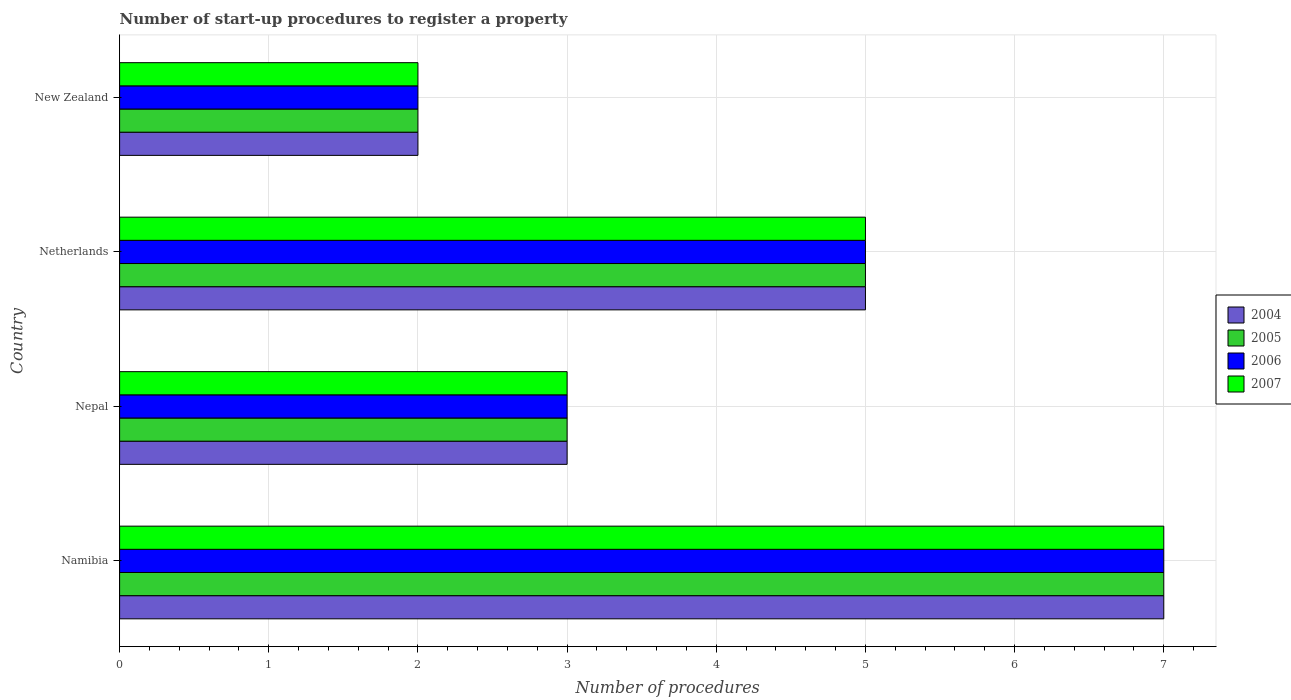How many different coloured bars are there?
Make the answer very short. 4. Are the number of bars per tick equal to the number of legend labels?
Your answer should be compact. Yes. Are the number of bars on each tick of the Y-axis equal?
Your answer should be very brief. Yes. What is the label of the 1st group of bars from the top?
Provide a short and direct response. New Zealand. What is the number of procedures required to register a property in 2007 in New Zealand?
Give a very brief answer. 2. Across all countries, what is the maximum number of procedures required to register a property in 2004?
Give a very brief answer. 7. In which country was the number of procedures required to register a property in 2004 maximum?
Keep it short and to the point. Namibia. In which country was the number of procedures required to register a property in 2004 minimum?
Give a very brief answer. New Zealand. What is the total number of procedures required to register a property in 2006 in the graph?
Your response must be concise. 17. What is the difference between the number of procedures required to register a property in 2006 in Nepal and that in Netherlands?
Keep it short and to the point. -2. What is the average number of procedures required to register a property in 2005 per country?
Provide a short and direct response. 4.25. What is the ratio of the number of procedures required to register a property in 2005 in Namibia to that in Nepal?
Offer a terse response. 2.33. What is the difference between the highest and the second highest number of procedures required to register a property in 2005?
Ensure brevity in your answer.  2. What is the difference between the highest and the lowest number of procedures required to register a property in 2007?
Make the answer very short. 5. Is it the case that in every country, the sum of the number of procedures required to register a property in 2007 and number of procedures required to register a property in 2006 is greater than the sum of number of procedures required to register a property in 2005 and number of procedures required to register a property in 2004?
Your answer should be very brief. No. What does the 2nd bar from the top in Namibia represents?
Your response must be concise. 2006. What does the 4th bar from the bottom in Namibia represents?
Give a very brief answer. 2007. Is it the case that in every country, the sum of the number of procedures required to register a property in 2006 and number of procedures required to register a property in 2004 is greater than the number of procedures required to register a property in 2007?
Provide a short and direct response. Yes. How many bars are there?
Your answer should be very brief. 16. Are all the bars in the graph horizontal?
Provide a short and direct response. Yes. How many countries are there in the graph?
Your answer should be compact. 4. Does the graph contain grids?
Provide a succinct answer. Yes. Where does the legend appear in the graph?
Make the answer very short. Center right. How many legend labels are there?
Give a very brief answer. 4. What is the title of the graph?
Keep it short and to the point. Number of start-up procedures to register a property. Does "1962" appear as one of the legend labels in the graph?
Your answer should be compact. No. What is the label or title of the X-axis?
Keep it short and to the point. Number of procedures. What is the label or title of the Y-axis?
Your response must be concise. Country. What is the Number of procedures of 2006 in Namibia?
Offer a terse response. 7. What is the Number of procedures of 2006 in Nepal?
Offer a terse response. 3. What is the Number of procedures of 2005 in Netherlands?
Offer a terse response. 5. What is the Number of procedures in 2006 in Netherlands?
Provide a succinct answer. 5. What is the Number of procedures in 2004 in New Zealand?
Your answer should be compact. 2. Across all countries, what is the maximum Number of procedures in 2004?
Offer a terse response. 7. Across all countries, what is the maximum Number of procedures of 2005?
Offer a very short reply. 7. Across all countries, what is the maximum Number of procedures of 2007?
Ensure brevity in your answer.  7. Across all countries, what is the minimum Number of procedures in 2006?
Your answer should be very brief. 2. Across all countries, what is the minimum Number of procedures in 2007?
Ensure brevity in your answer.  2. What is the total Number of procedures of 2007 in the graph?
Offer a terse response. 17. What is the difference between the Number of procedures of 2005 in Namibia and that in Nepal?
Ensure brevity in your answer.  4. What is the difference between the Number of procedures in 2006 in Namibia and that in Nepal?
Provide a succinct answer. 4. What is the difference between the Number of procedures in 2004 in Namibia and that in Netherlands?
Provide a succinct answer. 2. What is the difference between the Number of procedures of 2006 in Namibia and that in Netherlands?
Offer a terse response. 2. What is the difference between the Number of procedures of 2007 in Namibia and that in Netherlands?
Provide a short and direct response. 2. What is the difference between the Number of procedures of 2004 in Namibia and that in New Zealand?
Keep it short and to the point. 5. What is the difference between the Number of procedures in 2005 in Namibia and that in New Zealand?
Offer a terse response. 5. What is the difference between the Number of procedures of 2007 in Namibia and that in New Zealand?
Your response must be concise. 5. What is the difference between the Number of procedures in 2004 in Nepal and that in Netherlands?
Your answer should be compact. -2. What is the difference between the Number of procedures in 2006 in Nepal and that in Netherlands?
Offer a very short reply. -2. What is the difference between the Number of procedures of 2007 in Nepal and that in Netherlands?
Give a very brief answer. -2. What is the difference between the Number of procedures in 2005 in Nepal and that in New Zealand?
Keep it short and to the point. 1. What is the difference between the Number of procedures in 2006 in Nepal and that in New Zealand?
Provide a short and direct response. 1. What is the difference between the Number of procedures of 2007 in Nepal and that in New Zealand?
Offer a terse response. 1. What is the difference between the Number of procedures in 2004 in Netherlands and that in New Zealand?
Your response must be concise. 3. What is the difference between the Number of procedures of 2005 in Netherlands and that in New Zealand?
Ensure brevity in your answer.  3. What is the difference between the Number of procedures of 2007 in Netherlands and that in New Zealand?
Your answer should be compact. 3. What is the difference between the Number of procedures of 2005 in Namibia and the Number of procedures of 2006 in Nepal?
Offer a very short reply. 4. What is the difference between the Number of procedures of 2006 in Namibia and the Number of procedures of 2007 in Nepal?
Give a very brief answer. 4. What is the difference between the Number of procedures in 2005 in Namibia and the Number of procedures in 2006 in Netherlands?
Your answer should be compact. 2. What is the difference between the Number of procedures of 2005 in Namibia and the Number of procedures of 2007 in Netherlands?
Offer a very short reply. 2. What is the difference between the Number of procedures of 2006 in Namibia and the Number of procedures of 2007 in Netherlands?
Provide a short and direct response. 2. What is the difference between the Number of procedures in 2004 in Namibia and the Number of procedures in 2007 in New Zealand?
Your answer should be very brief. 5. What is the difference between the Number of procedures in 2005 in Namibia and the Number of procedures in 2007 in New Zealand?
Keep it short and to the point. 5. What is the difference between the Number of procedures of 2005 in Nepal and the Number of procedures of 2006 in Netherlands?
Offer a very short reply. -2. What is the difference between the Number of procedures in 2005 in Nepal and the Number of procedures in 2007 in Netherlands?
Provide a succinct answer. -2. What is the difference between the Number of procedures of 2004 in Nepal and the Number of procedures of 2006 in New Zealand?
Provide a short and direct response. 1. What is the difference between the Number of procedures of 2004 in Nepal and the Number of procedures of 2007 in New Zealand?
Ensure brevity in your answer.  1. What is the difference between the Number of procedures in 2006 in Nepal and the Number of procedures in 2007 in New Zealand?
Offer a very short reply. 1. What is the difference between the Number of procedures of 2004 in Netherlands and the Number of procedures of 2006 in New Zealand?
Your answer should be very brief. 3. What is the difference between the Number of procedures of 2004 in Netherlands and the Number of procedures of 2007 in New Zealand?
Keep it short and to the point. 3. What is the difference between the Number of procedures in 2005 in Netherlands and the Number of procedures in 2006 in New Zealand?
Your response must be concise. 3. What is the average Number of procedures in 2004 per country?
Provide a short and direct response. 4.25. What is the average Number of procedures in 2005 per country?
Offer a terse response. 4.25. What is the average Number of procedures of 2006 per country?
Your answer should be very brief. 4.25. What is the average Number of procedures in 2007 per country?
Your response must be concise. 4.25. What is the difference between the Number of procedures of 2004 and Number of procedures of 2006 in Namibia?
Keep it short and to the point. 0. What is the difference between the Number of procedures in 2005 and Number of procedures in 2006 in Namibia?
Give a very brief answer. 0. What is the difference between the Number of procedures of 2005 and Number of procedures of 2007 in Namibia?
Give a very brief answer. 0. What is the difference between the Number of procedures of 2004 and Number of procedures of 2005 in Nepal?
Ensure brevity in your answer.  0. What is the difference between the Number of procedures of 2004 and Number of procedures of 2007 in Nepal?
Ensure brevity in your answer.  0. What is the difference between the Number of procedures in 2005 and Number of procedures in 2006 in Nepal?
Provide a short and direct response. 0. What is the difference between the Number of procedures of 2005 and Number of procedures of 2007 in Netherlands?
Your answer should be very brief. 0. What is the difference between the Number of procedures of 2004 and Number of procedures of 2005 in New Zealand?
Keep it short and to the point. 0. What is the difference between the Number of procedures in 2004 and Number of procedures in 2006 in New Zealand?
Your response must be concise. 0. What is the difference between the Number of procedures of 2004 and Number of procedures of 2007 in New Zealand?
Provide a short and direct response. 0. What is the difference between the Number of procedures of 2005 and Number of procedures of 2006 in New Zealand?
Keep it short and to the point. 0. What is the difference between the Number of procedures of 2005 and Number of procedures of 2007 in New Zealand?
Make the answer very short. 0. What is the difference between the Number of procedures in 2006 and Number of procedures in 2007 in New Zealand?
Provide a succinct answer. 0. What is the ratio of the Number of procedures of 2004 in Namibia to that in Nepal?
Your answer should be compact. 2.33. What is the ratio of the Number of procedures of 2005 in Namibia to that in Nepal?
Your response must be concise. 2.33. What is the ratio of the Number of procedures in 2006 in Namibia to that in Nepal?
Ensure brevity in your answer.  2.33. What is the ratio of the Number of procedures of 2007 in Namibia to that in Nepal?
Your answer should be compact. 2.33. What is the ratio of the Number of procedures of 2004 in Namibia to that in Netherlands?
Ensure brevity in your answer.  1.4. What is the ratio of the Number of procedures in 2006 in Namibia to that in Netherlands?
Provide a short and direct response. 1.4. What is the ratio of the Number of procedures in 2005 in Namibia to that in New Zealand?
Your answer should be compact. 3.5. What is the ratio of the Number of procedures in 2004 in Nepal to that in Netherlands?
Your response must be concise. 0.6. What is the ratio of the Number of procedures of 2006 in Nepal to that in Netherlands?
Ensure brevity in your answer.  0.6. What is the ratio of the Number of procedures of 2004 in Nepal to that in New Zealand?
Make the answer very short. 1.5. What is the ratio of the Number of procedures of 2006 in Netherlands to that in New Zealand?
Offer a terse response. 2.5. What is the ratio of the Number of procedures of 2007 in Netherlands to that in New Zealand?
Make the answer very short. 2.5. What is the difference between the highest and the second highest Number of procedures in 2004?
Your response must be concise. 2. What is the difference between the highest and the second highest Number of procedures in 2005?
Offer a terse response. 2. What is the difference between the highest and the second highest Number of procedures in 2006?
Your answer should be compact. 2. What is the difference between the highest and the lowest Number of procedures of 2005?
Offer a terse response. 5. 